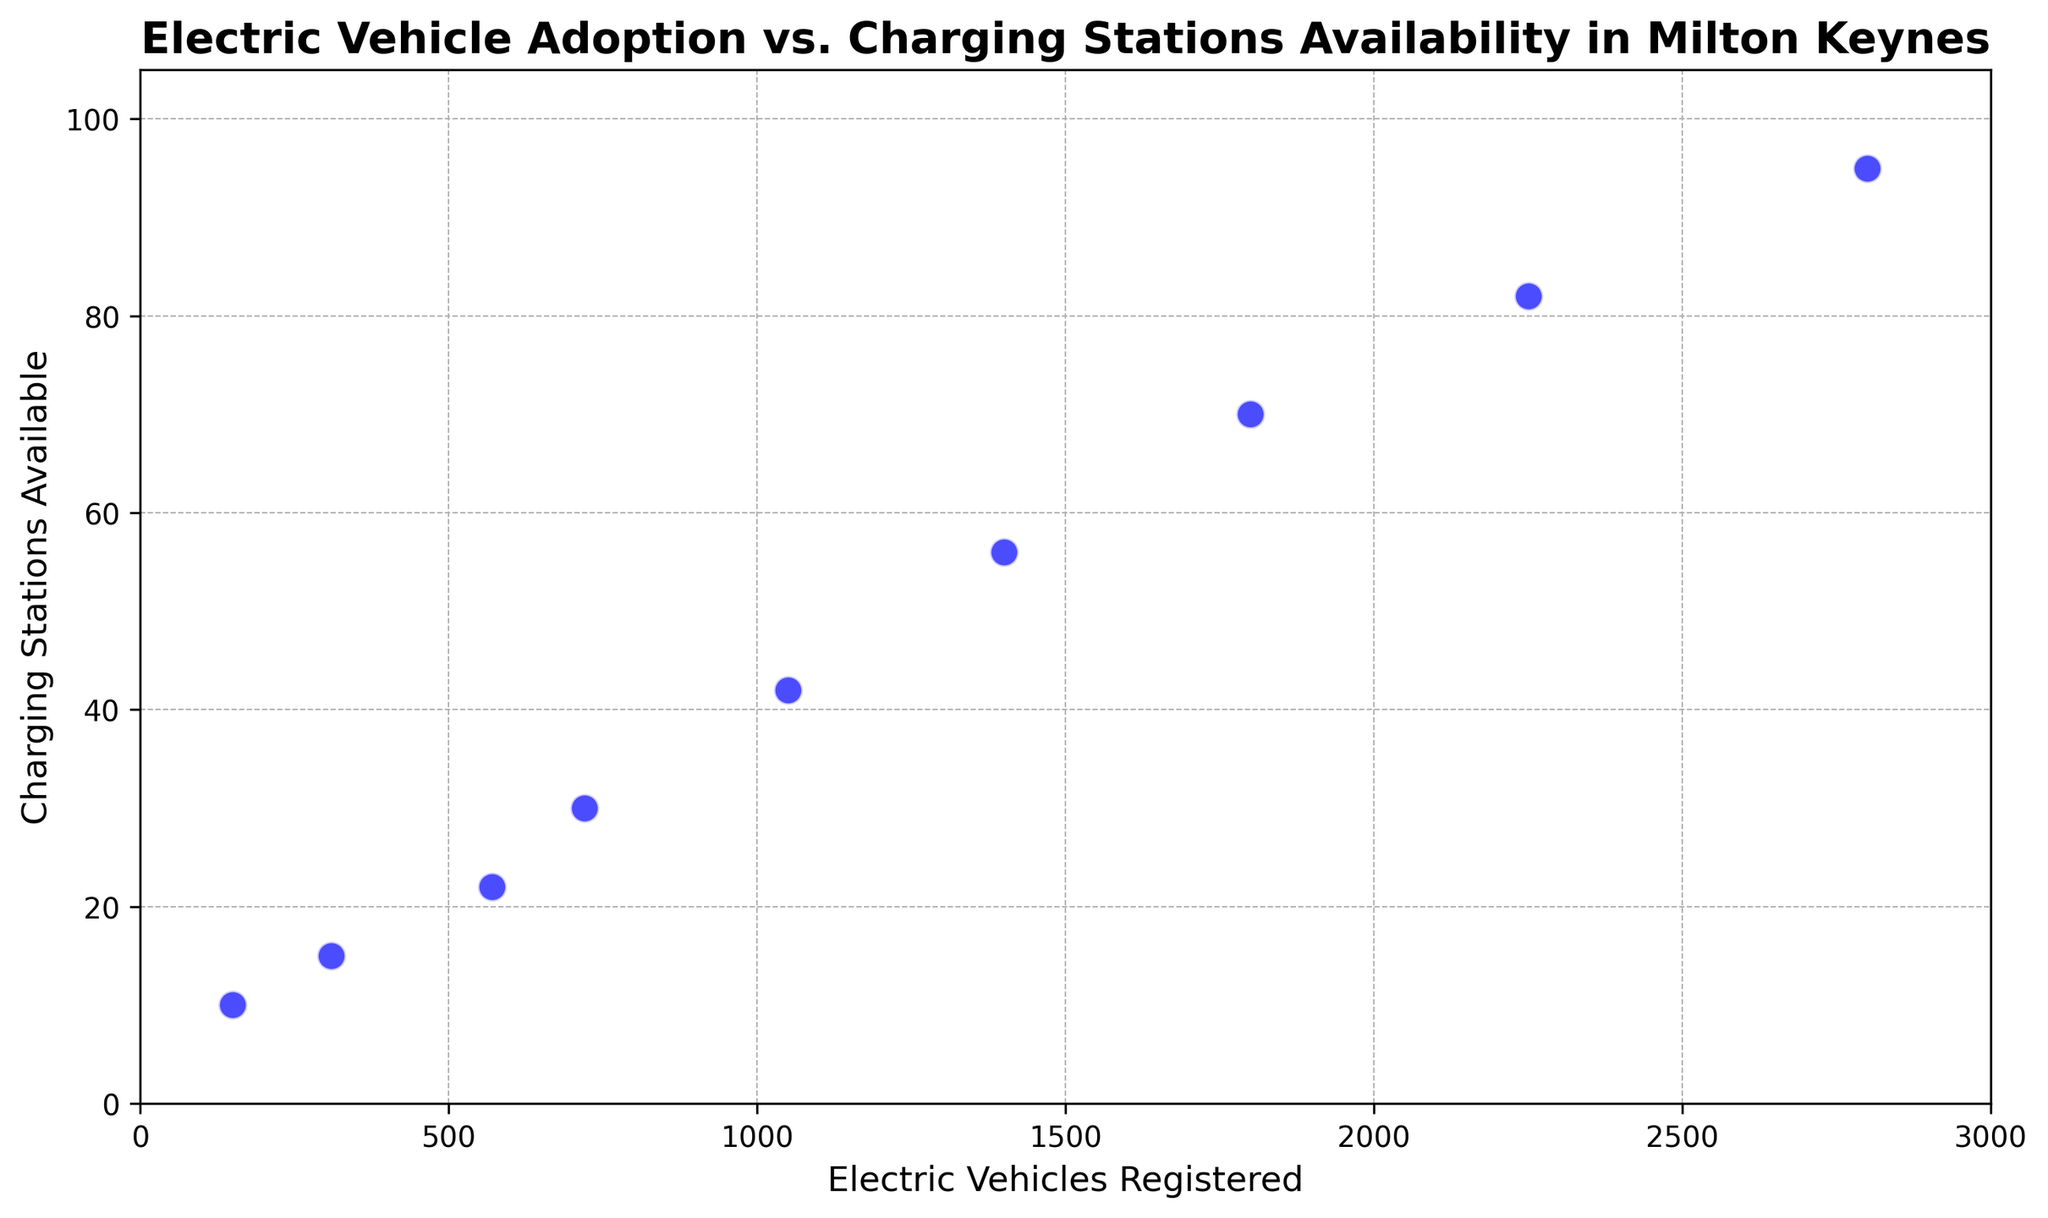what's the total number of electric vehicles registered from 2015 to 2023? Sum all the values for "Electric Vehicles Registered" from the data: 150 + 310 + 570 + 720 + 1050 + 1400 + 1800 + 2250 + 2800 = 10050
Answer: 10050 what year showed the largest increase in electric vehicles registered compared to the previous year? Calculate the year-on-year changes: 2016: 310 - 150 = 160, 2017: 570 - 310 = 260, 2018: 720 - 570 = 150, 2019: 1050 - 720 = 330, 2020: 1400 - 1050 = 350, 2021: 1800 - 1400 = 400, 2022: 2250 - 1800 = 450, 2023: 2800 - 2250 = 550. The largest increase is from 2022 to 2023.
Answer: 2023 what's the average number of charging stations available over the recorded years? Sum all the values for "Charging Stations Available": 10 + 15 + 22 + 30 + 42 + 56 + 70 + 82 + 95 = 422, then divide by the number of years, 422 / 9 ≈ 46.89
Answer: 46.89 how many more charging stations were there in 2023 compared to 2015? Subtract the number of charging stations in 2015 from the number in 2023: 95 - 10 = 85
Answer: 85 which year had exactly 30 charging stations available? Refer to the data to see that 2018 had exactly 30 charging stations available
Answer: 2018 was there any year where the number of charging stations available did not increase? Compare the "Charging Stations Available" values year-on-year, noting that it increases every year from 2015 to 2023.
Answer: No which has a higher value in 2019: the increase in electric vehicles or the increase in charging stations compared to the previous year? Calculate the increase from 2018 to 2019 for electric vehicles (1050 - 720 = 330) and for charging stations (42 - 30 = 12). Electric vehicles increased by 330 while charging stations increased by 12.
Answer: Electric vehicles how does the number of electric vehicles registered in 2021 compare to the number in 2020? Compare the values: 1800 (2021) - 1400 (2020) = 400 more electric vehicles registered in 2021 than in 2020.
Answer: 400 more have the number of charging stations increased proportionally with the number of electric vehicles registered? Analyze the trend from the scatter plot and data; both metrics show an increasing trend, but the rate of increase in electric vehicles is steeper than that of charging stations, indicating they are not perfectly proportional.
Answer: No what percentage of the total electric vehicles registered in 2023 accounts for all vehicles registered from 2015 to 2023? Calculate the percentage: (2800 / 10050) * 100 ≈ 27.86%
Answer: 27.86% 